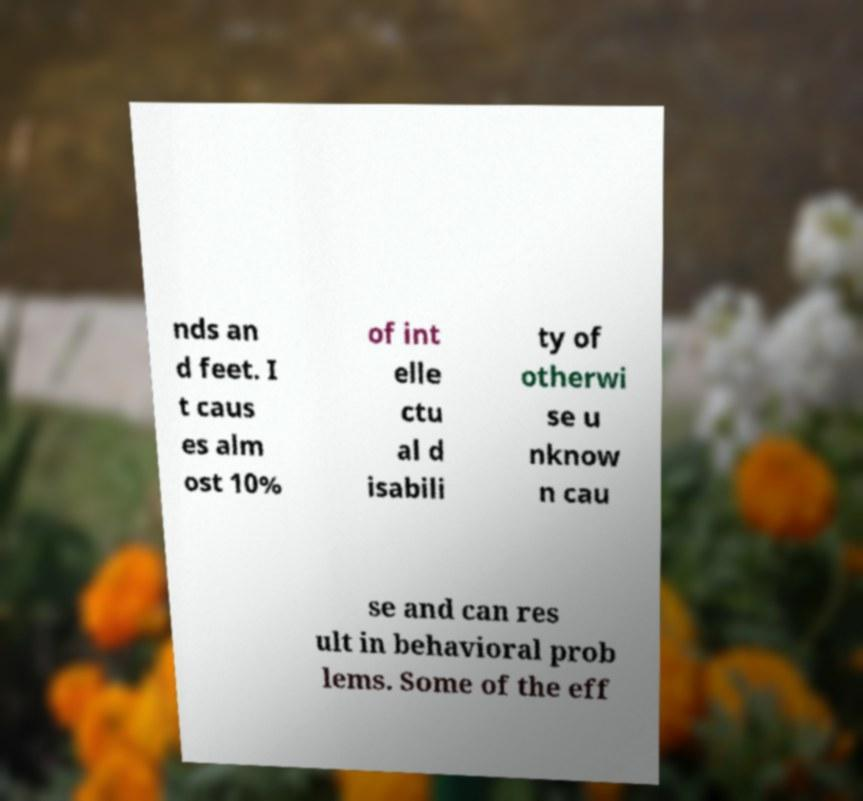Could you assist in decoding the text presented in this image and type it out clearly? nds an d feet. I t caus es alm ost 10% of int elle ctu al d isabili ty of otherwi se u nknow n cau se and can res ult in behavioral prob lems. Some of the eff 